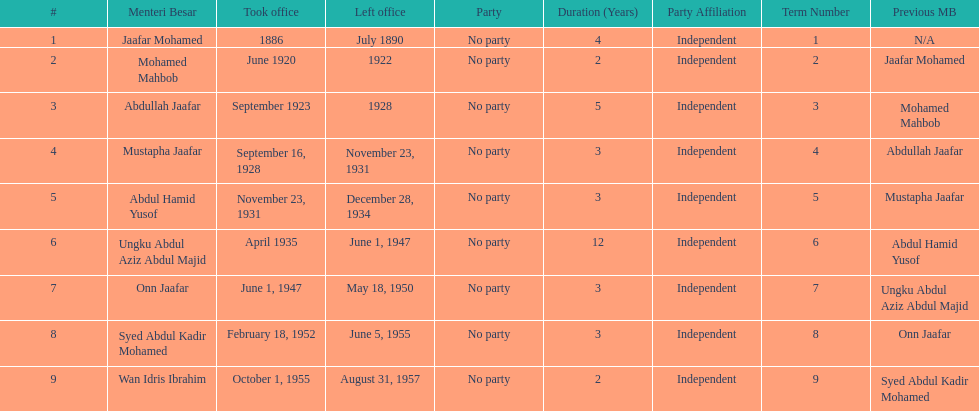How many years was jaafar mohamed in office? 4. 